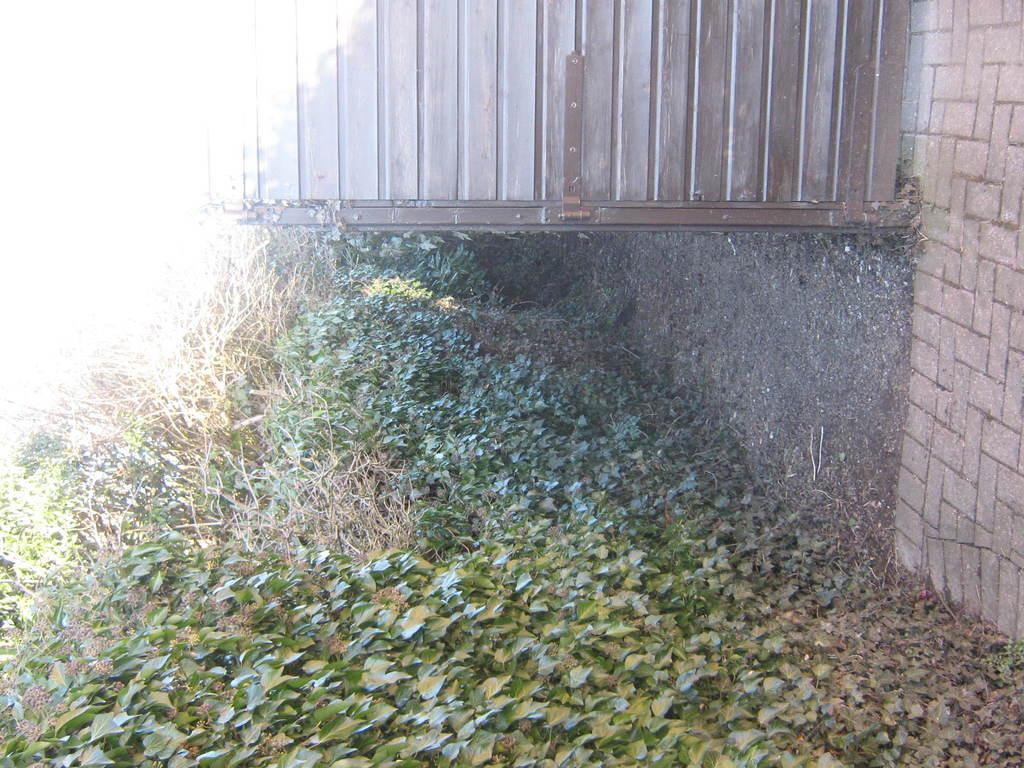Can you describe this image briefly? In this image there is a wall. Beside the wall there is the ground. There are plants, grass and dried leaves on the ground. At the top there is a metal railing to the wall. 